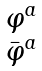<formula> <loc_0><loc_0><loc_500><loc_500>\begin{matrix} \varphi ^ { a } \\ \bar { \varphi } ^ { a } \end{matrix}</formula> 